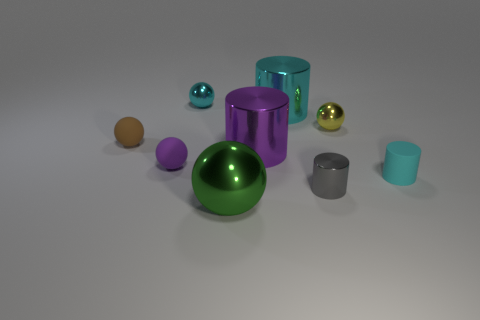Subtract all yellow balls. How many balls are left? 4 Subtract 1 spheres. How many spheres are left? 4 Subtract all yellow shiny spheres. How many spheres are left? 4 Subtract all red spheres. Subtract all purple cylinders. How many spheres are left? 5 Add 1 spheres. How many objects exist? 10 Subtract all balls. How many objects are left? 4 Add 5 large green spheres. How many large green spheres exist? 6 Subtract 0 green cylinders. How many objects are left? 9 Subtract all big cyan shiny cubes. Subtract all gray metallic objects. How many objects are left? 8 Add 8 purple rubber objects. How many purple rubber objects are left? 9 